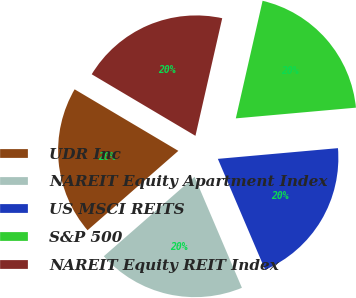Convert chart. <chart><loc_0><loc_0><loc_500><loc_500><pie_chart><fcel>UDR Inc<fcel>NAREIT Equity Apartment Index<fcel>US MSCI REITS<fcel>S&P 500<fcel>NAREIT Equity REIT Index<nl><fcel>19.96%<fcel>19.98%<fcel>20.0%<fcel>20.02%<fcel>20.04%<nl></chart> 